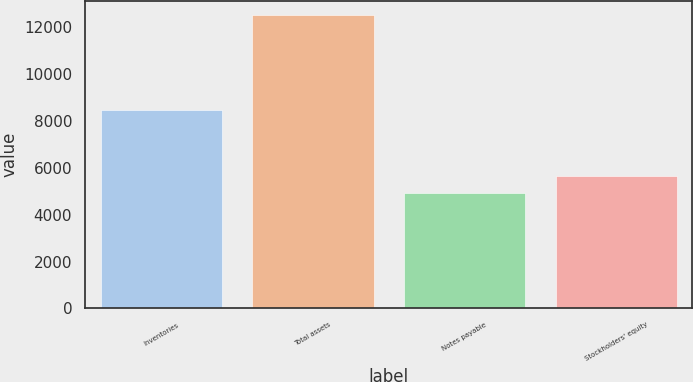<chart> <loc_0><loc_0><loc_500><loc_500><bar_chart><fcel>Inventories<fcel>Total assets<fcel>Notes payable<fcel>Stockholders' equity<nl><fcel>8486.8<fcel>12514.8<fcel>4909.6<fcel>5670.12<nl></chart> 